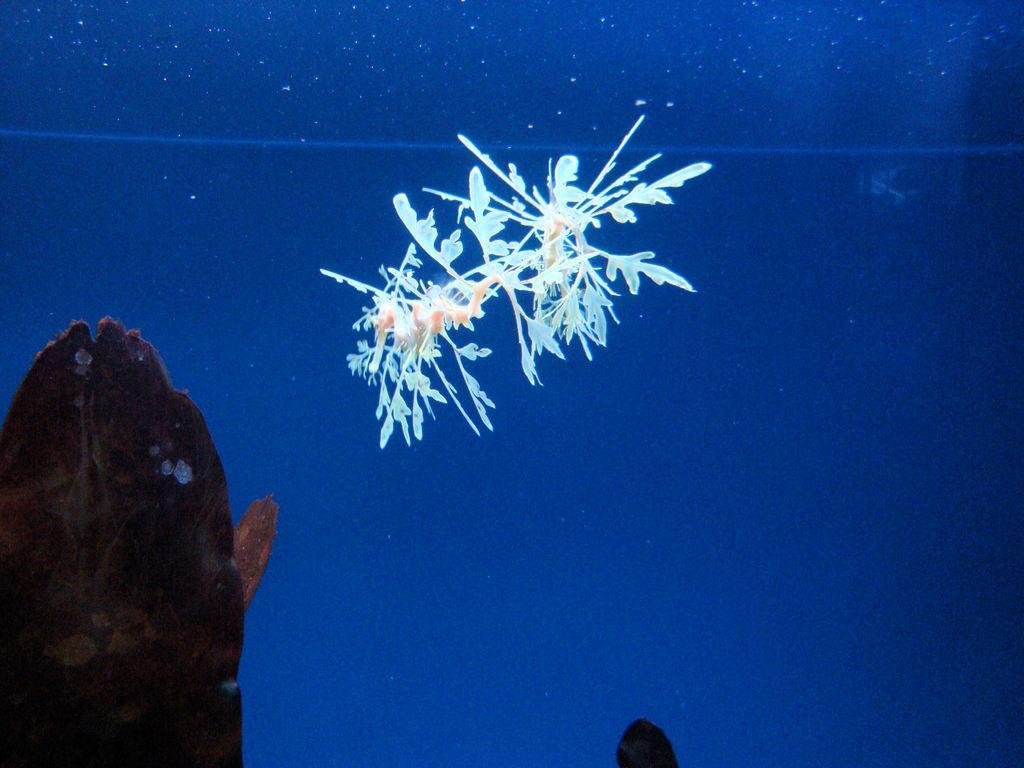Can you describe this image briefly? In this picture we can observe a plant which is in white color in the water. The background is in blue color. On the left side there is an object which is in brown color. 